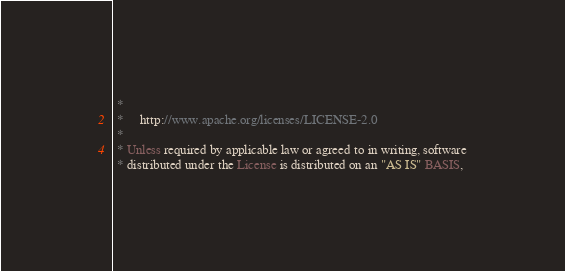<code> <loc_0><loc_0><loc_500><loc_500><_Scala_> *
 *     http://www.apache.org/licenses/LICENSE-2.0
 *
 * Unless required by applicable law or agreed to in writing, software
 * distributed under the License is distributed on an "AS IS" BASIS,</code> 